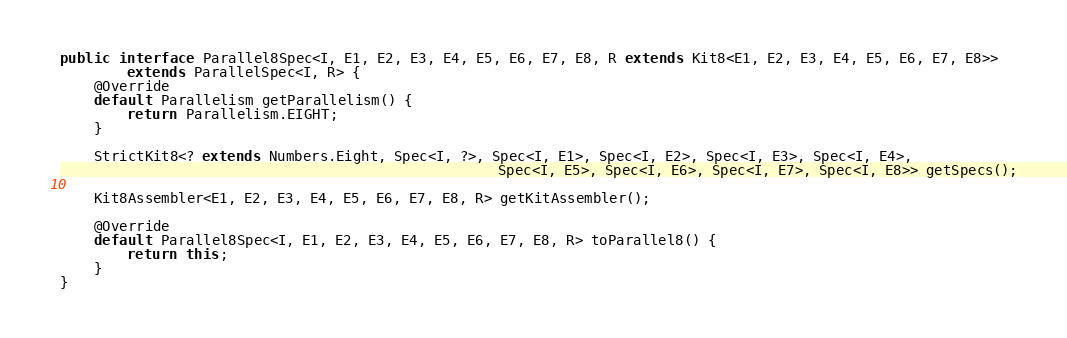<code> <loc_0><loc_0><loc_500><loc_500><_Java_>public interface Parallel8Spec<I, E1, E2, E3, E4, E5, E6, E7, E8, R extends Kit8<E1, E2, E3, E4, E5, E6, E7, E8>>
        extends ParallelSpec<I, R> {
    @Override
    default Parallelism getParallelism() {
        return Parallelism.EIGHT;
    }

    StrictKit8<? extends Numbers.Eight, Spec<I, ?>, Spec<I, E1>, Spec<I, E2>, Spec<I, E3>, Spec<I, E4>,
                                                    Spec<I, E5>, Spec<I, E6>, Spec<I, E7>, Spec<I, E8>> getSpecs();

    Kit8Assembler<E1, E2, E3, E4, E5, E6, E7, E8, R> getKitAssembler();

    @Override
    default Parallel8Spec<I, E1, E2, E3, E4, E5, E6, E7, E8, R> toParallel8() {
        return this;
    }
}
</code> 